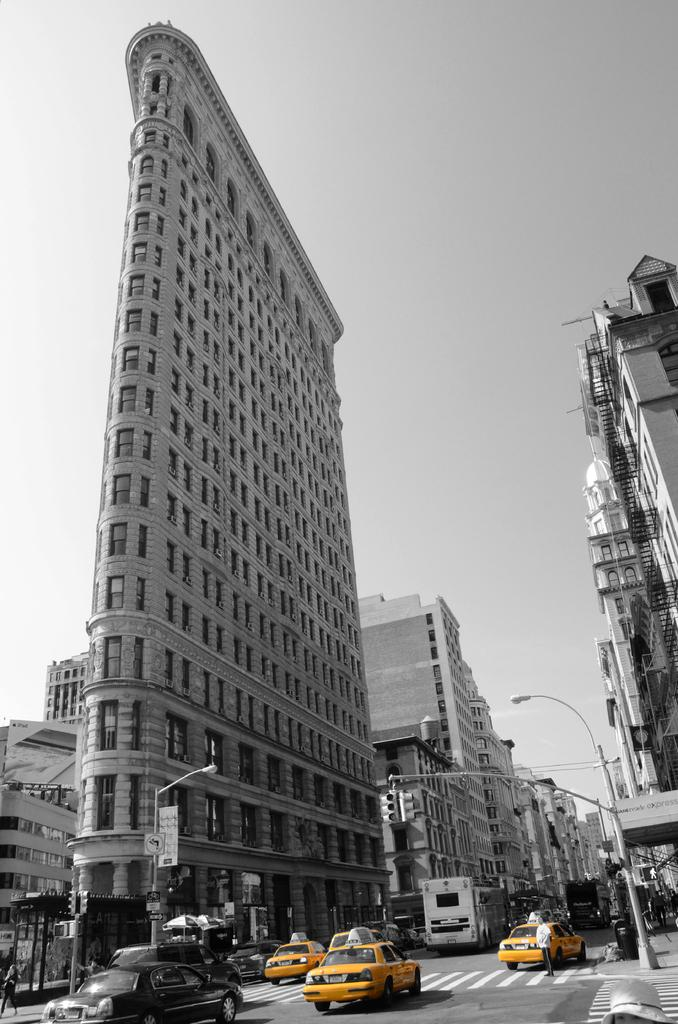What is the main subject of the image? The main subject of the image is many cars on the road. What can be seen on either side of the road in the image? There are buildings on either side of the road in the image. What is visible in the background of the image? The sky is visible in the image. What is the color scheme of the image? The image is black and white. What type of birthday discovery led to the increased profit in the image? There is no mention of a birthday, discovery, or profit in the image; it primarily features cars on the road and buildings on either side of the road. 